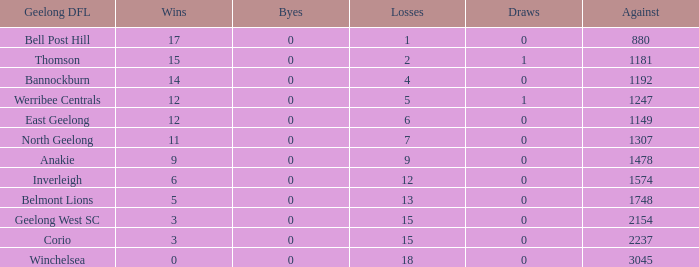What is the standard of triumphs when the byes are under 0? None. 